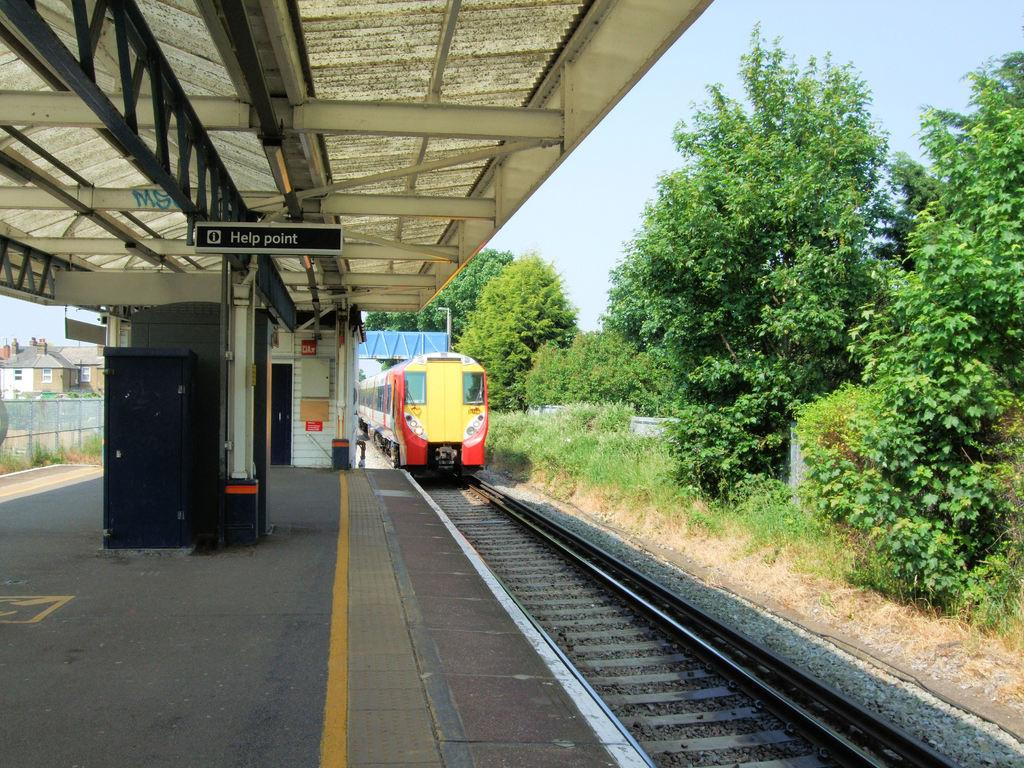<image>
Write a terse but informative summary of the picture. A sign designates the area as the "Help Point." 